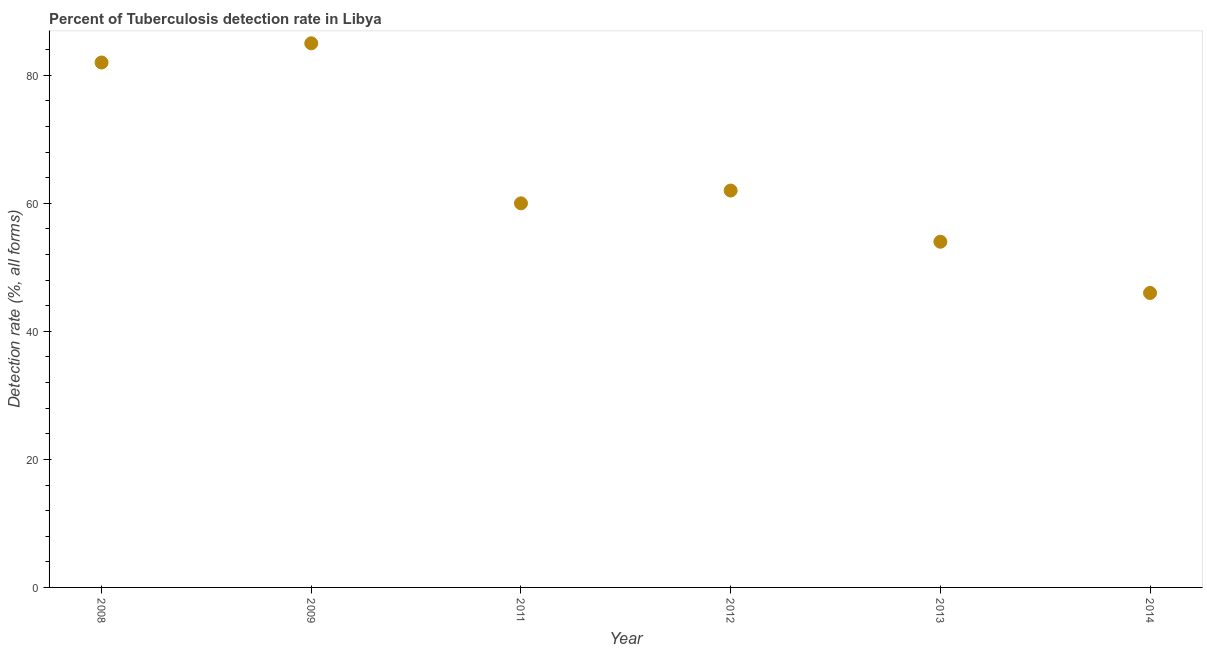What is the detection rate of tuberculosis in 2012?
Offer a very short reply. 62. Across all years, what is the maximum detection rate of tuberculosis?
Offer a very short reply. 85. Across all years, what is the minimum detection rate of tuberculosis?
Your answer should be compact. 46. In which year was the detection rate of tuberculosis maximum?
Your response must be concise. 2009. What is the sum of the detection rate of tuberculosis?
Your answer should be compact. 389. What is the difference between the detection rate of tuberculosis in 2009 and 2013?
Keep it short and to the point. 31. What is the average detection rate of tuberculosis per year?
Provide a short and direct response. 64.83. What is the median detection rate of tuberculosis?
Offer a very short reply. 61. In how many years, is the detection rate of tuberculosis greater than 28 %?
Provide a succinct answer. 6. What is the ratio of the detection rate of tuberculosis in 2009 to that in 2012?
Provide a short and direct response. 1.37. Is the detection rate of tuberculosis in 2011 less than that in 2014?
Your answer should be compact. No. Is the sum of the detection rate of tuberculosis in 2011 and 2014 greater than the maximum detection rate of tuberculosis across all years?
Offer a terse response. Yes. What is the difference between the highest and the lowest detection rate of tuberculosis?
Offer a very short reply. 39. How many years are there in the graph?
Keep it short and to the point. 6. Are the values on the major ticks of Y-axis written in scientific E-notation?
Provide a short and direct response. No. Does the graph contain any zero values?
Give a very brief answer. No. What is the title of the graph?
Offer a very short reply. Percent of Tuberculosis detection rate in Libya. What is the label or title of the Y-axis?
Offer a very short reply. Detection rate (%, all forms). What is the Detection rate (%, all forms) in 2009?
Offer a very short reply. 85. What is the Detection rate (%, all forms) in 2011?
Keep it short and to the point. 60. What is the Detection rate (%, all forms) in 2013?
Keep it short and to the point. 54. What is the difference between the Detection rate (%, all forms) in 2008 and 2013?
Provide a short and direct response. 28. What is the difference between the Detection rate (%, all forms) in 2009 and 2013?
Offer a terse response. 31. What is the difference between the Detection rate (%, all forms) in 2009 and 2014?
Give a very brief answer. 39. What is the difference between the Detection rate (%, all forms) in 2011 and 2012?
Your answer should be very brief. -2. What is the difference between the Detection rate (%, all forms) in 2011 and 2014?
Ensure brevity in your answer.  14. What is the difference between the Detection rate (%, all forms) in 2012 and 2013?
Offer a very short reply. 8. What is the difference between the Detection rate (%, all forms) in 2013 and 2014?
Make the answer very short. 8. What is the ratio of the Detection rate (%, all forms) in 2008 to that in 2011?
Offer a very short reply. 1.37. What is the ratio of the Detection rate (%, all forms) in 2008 to that in 2012?
Provide a short and direct response. 1.32. What is the ratio of the Detection rate (%, all forms) in 2008 to that in 2013?
Ensure brevity in your answer.  1.52. What is the ratio of the Detection rate (%, all forms) in 2008 to that in 2014?
Ensure brevity in your answer.  1.78. What is the ratio of the Detection rate (%, all forms) in 2009 to that in 2011?
Offer a very short reply. 1.42. What is the ratio of the Detection rate (%, all forms) in 2009 to that in 2012?
Make the answer very short. 1.37. What is the ratio of the Detection rate (%, all forms) in 2009 to that in 2013?
Provide a succinct answer. 1.57. What is the ratio of the Detection rate (%, all forms) in 2009 to that in 2014?
Provide a short and direct response. 1.85. What is the ratio of the Detection rate (%, all forms) in 2011 to that in 2013?
Offer a very short reply. 1.11. What is the ratio of the Detection rate (%, all forms) in 2011 to that in 2014?
Ensure brevity in your answer.  1.3. What is the ratio of the Detection rate (%, all forms) in 2012 to that in 2013?
Your response must be concise. 1.15. What is the ratio of the Detection rate (%, all forms) in 2012 to that in 2014?
Keep it short and to the point. 1.35. What is the ratio of the Detection rate (%, all forms) in 2013 to that in 2014?
Keep it short and to the point. 1.17. 